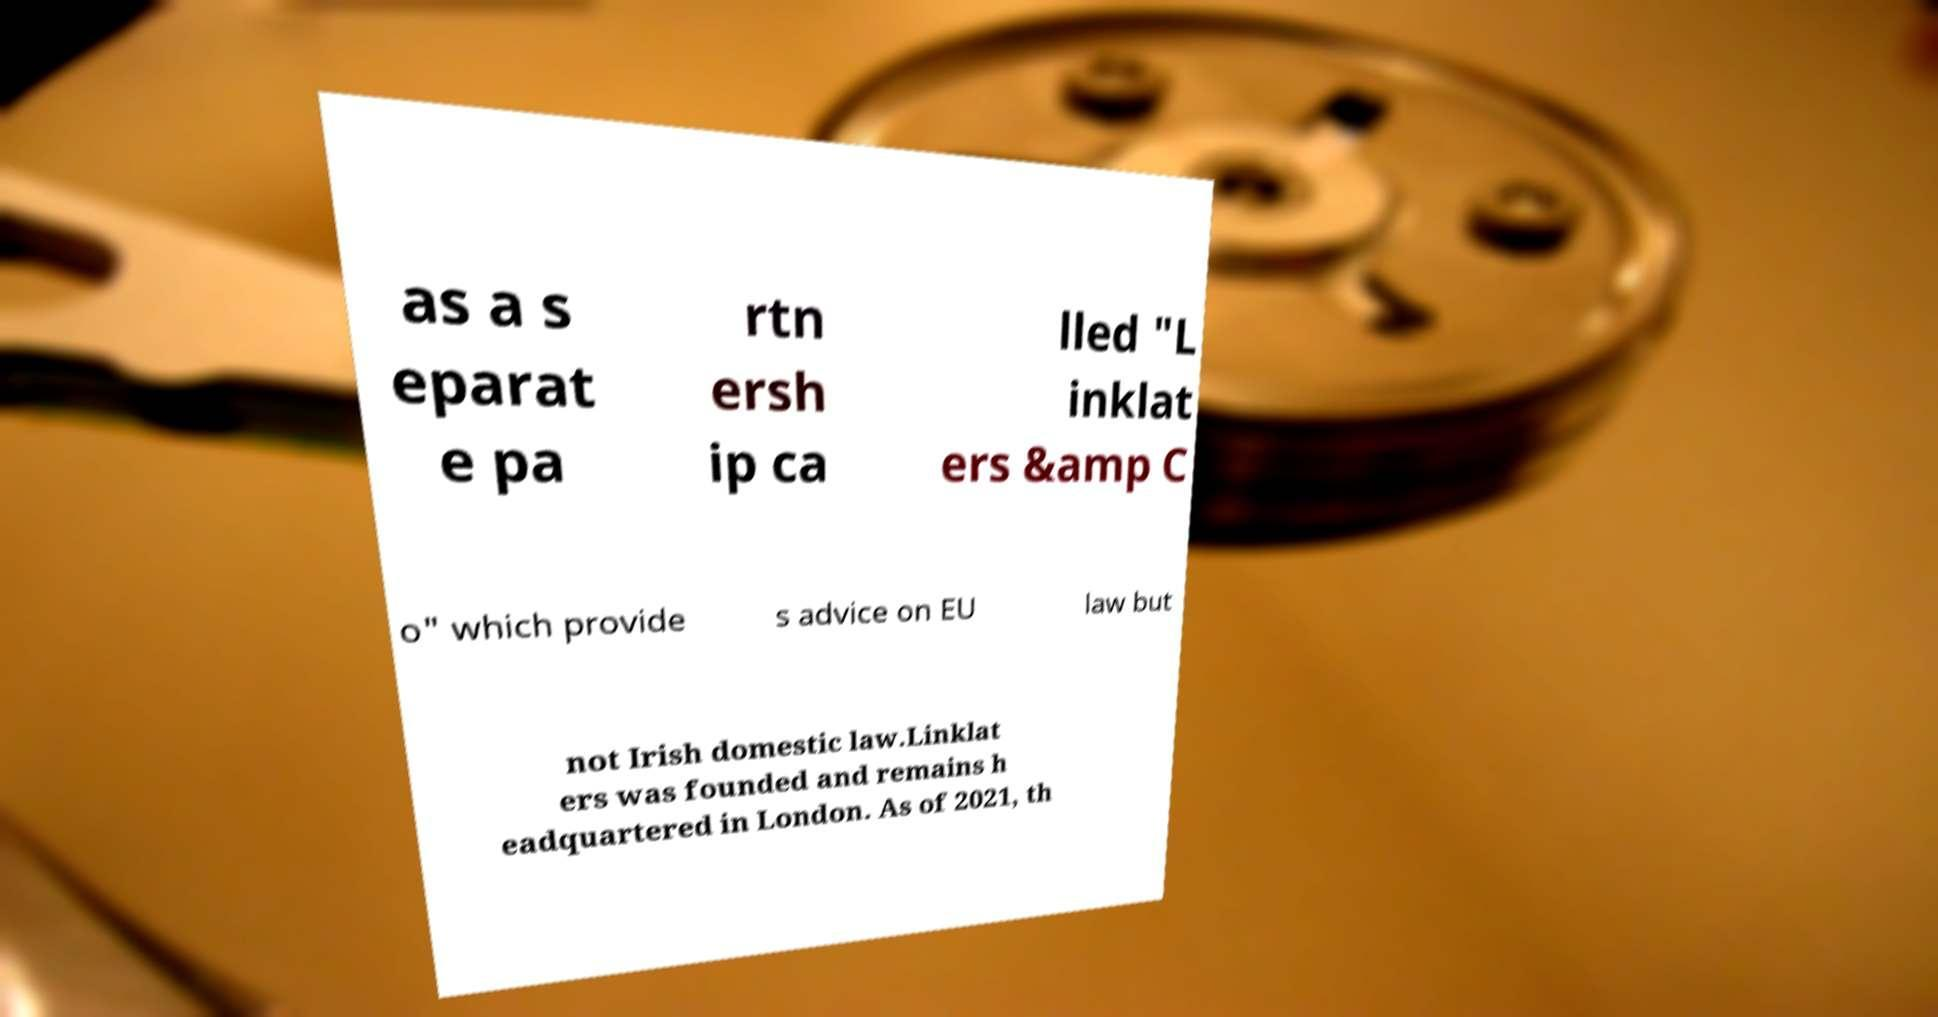Can you read and provide the text displayed in the image?This photo seems to have some interesting text. Can you extract and type it out for me? as a s eparat e pa rtn ersh ip ca lled "L inklat ers &amp C o" which provide s advice on EU law but not Irish domestic law.Linklat ers was founded and remains h eadquartered in London. As of 2021, th 